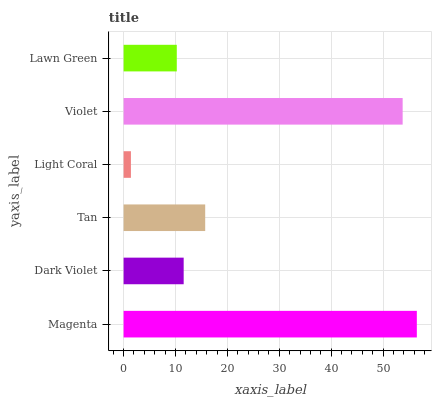Is Light Coral the minimum?
Answer yes or no. Yes. Is Magenta the maximum?
Answer yes or no. Yes. Is Dark Violet the minimum?
Answer yes or no. No. Is Dark Violet the maximum?
Answer yes or no. No. Is Magenta greater than Dark Violet?
Answer yes or no. Yes. Is Dark Violet less than Magenta?
Answer yes or no. Yes. Is Dark Violet greater than Magenta?
Answer yes or no. No. Is Magenta less than Dark Violet?
Answer yes or no. No. Is Tan the high median?
Answer yes or no. Yes. Is Dark Violet the low median?
Answer yes or no. Yes. Is Light Coral the high median?
Answer yes or no. No. Is Lawn Green the low median?
Answer yes or no. No. 